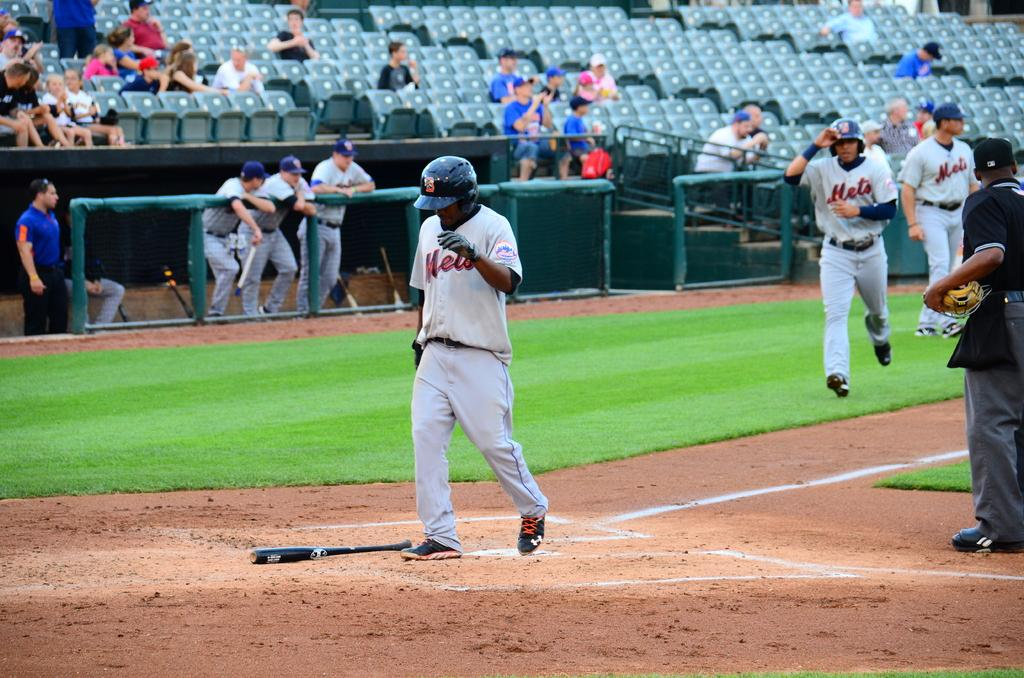Provide a one-sentence caption for the provided image. A baseball player that plays for the Mets crossing home plate with another runner behind him. 